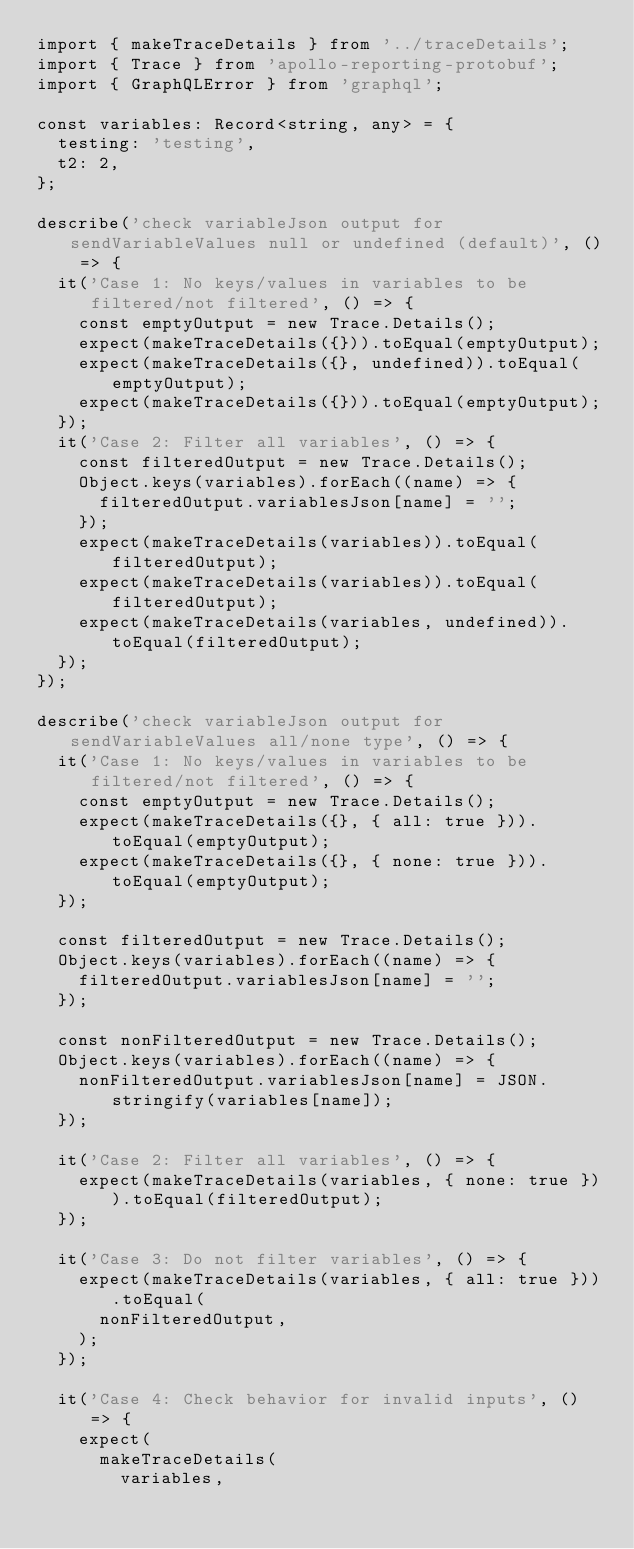<code> <loc_0><loc_0><loc_500><loc_500><_TypeScript_>import { makeTraceDetails } from '../traceDetails';
import { Trace } from 'apollo-reporting-protobuf';
import { GraphQLError } from 'graphql';

const variables: Record<string, any> = {
  testing: 'testing',
  t2: 2,
};

describe('check variableJson output for sendVariableValues null or undefined (default)', () => {
  it('Case 1: No keys/values in variables to be filtered/not filtered', () => {
    const emptyOutput = new Trace.Details();
    expect(makeTraceDetails({})).toEqual(emptyOutput);
    expect(makeTraceDetails({}, undefined)).toEqual(emptyOutput);
    expect(makeTraceDetails({})).toEqual(emptyOutput);
  });
  it('Case 2: Filter all variables', () => {
    const filteredOutput = new Trace.Details();
    Object.keys(variables).forEach((name) => {
      filteredOutput.variablesJson[name] = '';
    });
    expect(makeTraceDetails(variables)).toEqual(filteredOutput);
    expect(makeTraceDetails(variables)).toEqual(filteredOutput);
    expect(makeTraceDetails(variables, undefined)).toEqual(filteredOutput);
  });
});

describe('check variableJson output for sendVariableValues all/none type', () => {
  it('Case 1: No keys/values in variables to be filtered/not filtered', () => {
    const emptyOutput = new Trace.Details();
    expect(makeTraceDetails({}, { all: true })).toEqual(emptyOutput);
    expect(makeTraceDetails({}, { none: true })).toEqual(emptyOutput);
  });

  const filteredOutput = new Trace.Details();
  Object.keys(variables).forEach((name) => {
    filteredOutput.variablesJson[name] = '';
  });

  const nonFilteredOutput = new Trace.Details();
  Object.keys(variables).forEach((name) => {
    nonFilteredOutput.variablesJson[name] = JSON.stringify(variables[name]);
  });

  it('Case 2: Filter all variables', () => {
    expect(makeTraceDetails(variables, { none: true })).toEqual(filteredOutput);
  });

  it('Case 3: Do not filter variables', () => {
    expect(makeTraceDetails(variables, { all: true })).toEqual(
      nonFilteredOutput,
    );
  });

  it('Case 4: Check behavior for invalid inputs', () => {
    expect(
      makeTraceDetails(
        variables,</code> 